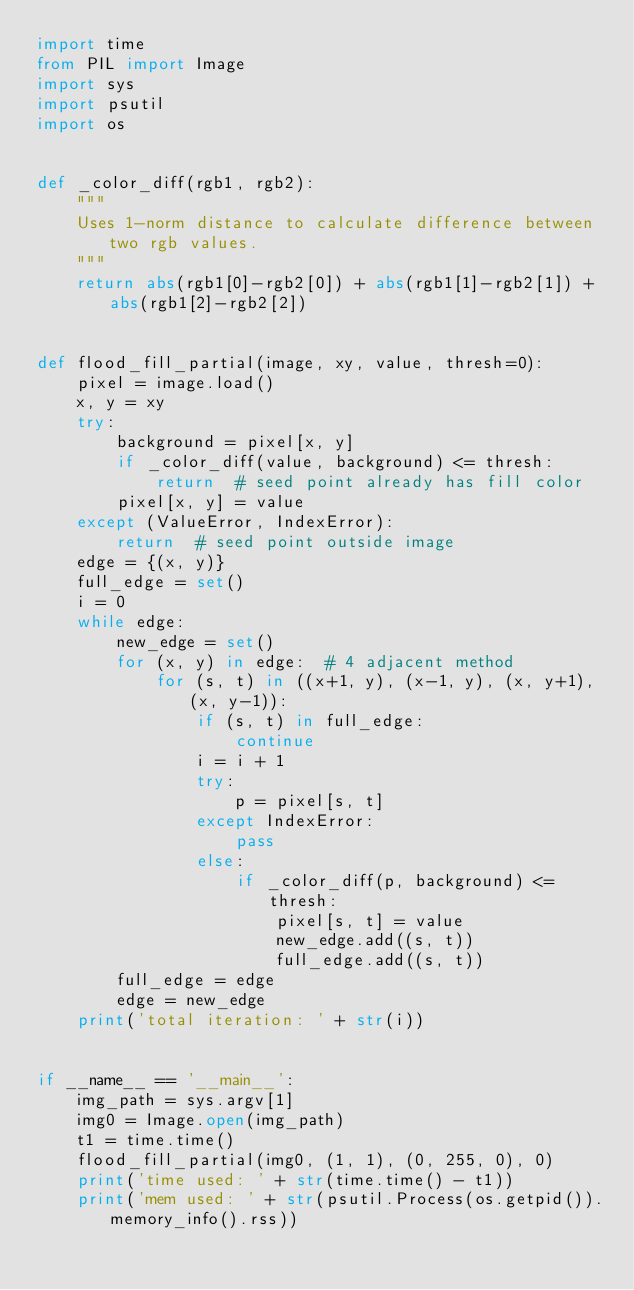Convert code to text. <code><loc_0><loc_0><loc_500><loc_500><_Python_>import time
from PIL import Image
import sys
import psutil
import os


def _color_diff(rgb1, rgb2):
    """
    Uses 1-norm distance to calculate difference between two rgb values.
    """
    return abs(rgb1[0]-rgb2[0]) + abs(rgb1[1]-rgb2[1]) + abs(rgb1[2]-rgb2[2])


def flood_fill_partial(image, xy, value, thresh=0):
    pixel = image.load()
    x, y = xy
    try:
        background = pixel[x, y]
        if _color_diff(value, background) <= thresh:
            return  # seed point already has fill color
        pixel[x, y] = value
    except (ValueError, IndexError):
        return  # seed point outside image
    edge = {(x, y)}
    full_edge = set()
    i = 0
    while edge:
        new_edge = set()
        for (x, y) in edge:  # 4 adjacent method
            for (s, t) in ((x+1, y), (x-1, y), (x, y+1), (x, y-1)):
                if (s, t) in full_edge:
                    continue
                i = i + 1
                try:
                    p = pixel[s, t]
                except IndexError:
                    pass
                else:
                    if _color_diff(p, background) <= thresh:
                        pixel[s, t] = value
                        new_edge.add((s, t))
                        full_edge.add((s, t))
        full_edge = edge
        edge = new_edge
    print('total iteration: ' + str(i))


if __name__ == '__main__':
    img_path = sys.argv[1]
    img0 = Image.open(img_path)
    t1 = time.time()
    flood_fill_partial(img0, (1, 1), (0, 255, 0), 0)
    print('time used: ' + str(time.time() - t1))
    print('mem used: ' + str(psutil.Process(os.getpid()).memory_info().rss))

</code> 